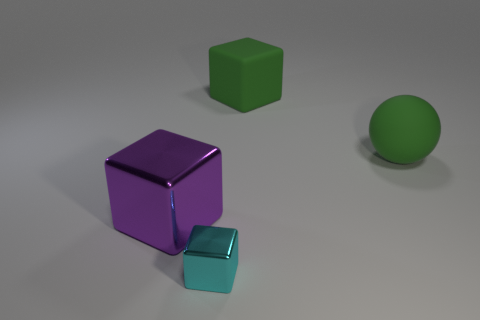Add 3 big purple shiny objects. How many objects exist? 7 Subtract all balls. How many objects are left? 3 Add 4 small cyan cubes. How many small cyan cubes are left? 5 Add 3 large things. How many large things exist? 6 Subtract 1 green spheres. How many objects are left? 3 Subtract all yellow metallic blocks. Subtract all big green rubber objects. How many objects are left? 2 